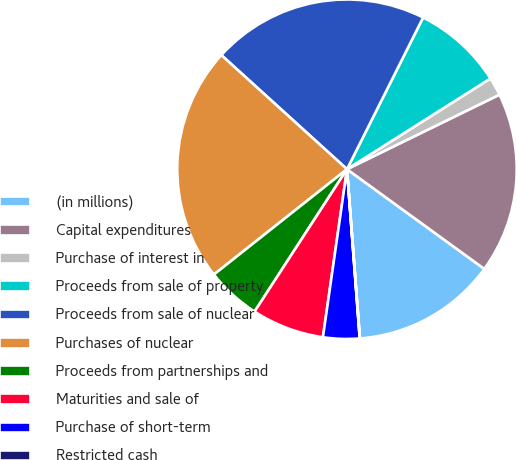<chart> <loc_0><loc_0><loc_500><loc_500><pie_chart><fcel>(in millions)<fcel>Capital expenditures<fcel>Purchase of interest in<fcel>Proceeds from sale of property<fcel>Proceeds from sale of nuclear<fcel>Purchases of nuclear<fcel>Proceeds from partnerships and<fcel>Maturities and sale of<fcel>Purchase of short-term<fcel>Restricted cash<nl><fcel>13.79%<fcel>17.23%<fcel>1.74%<fcel>8.62%<fcel>20.67%<fcel>22.39%<fcel>5.18%<fcel>6.9%<fcel>3.46%<fcel>0.02%<nl></chart> 